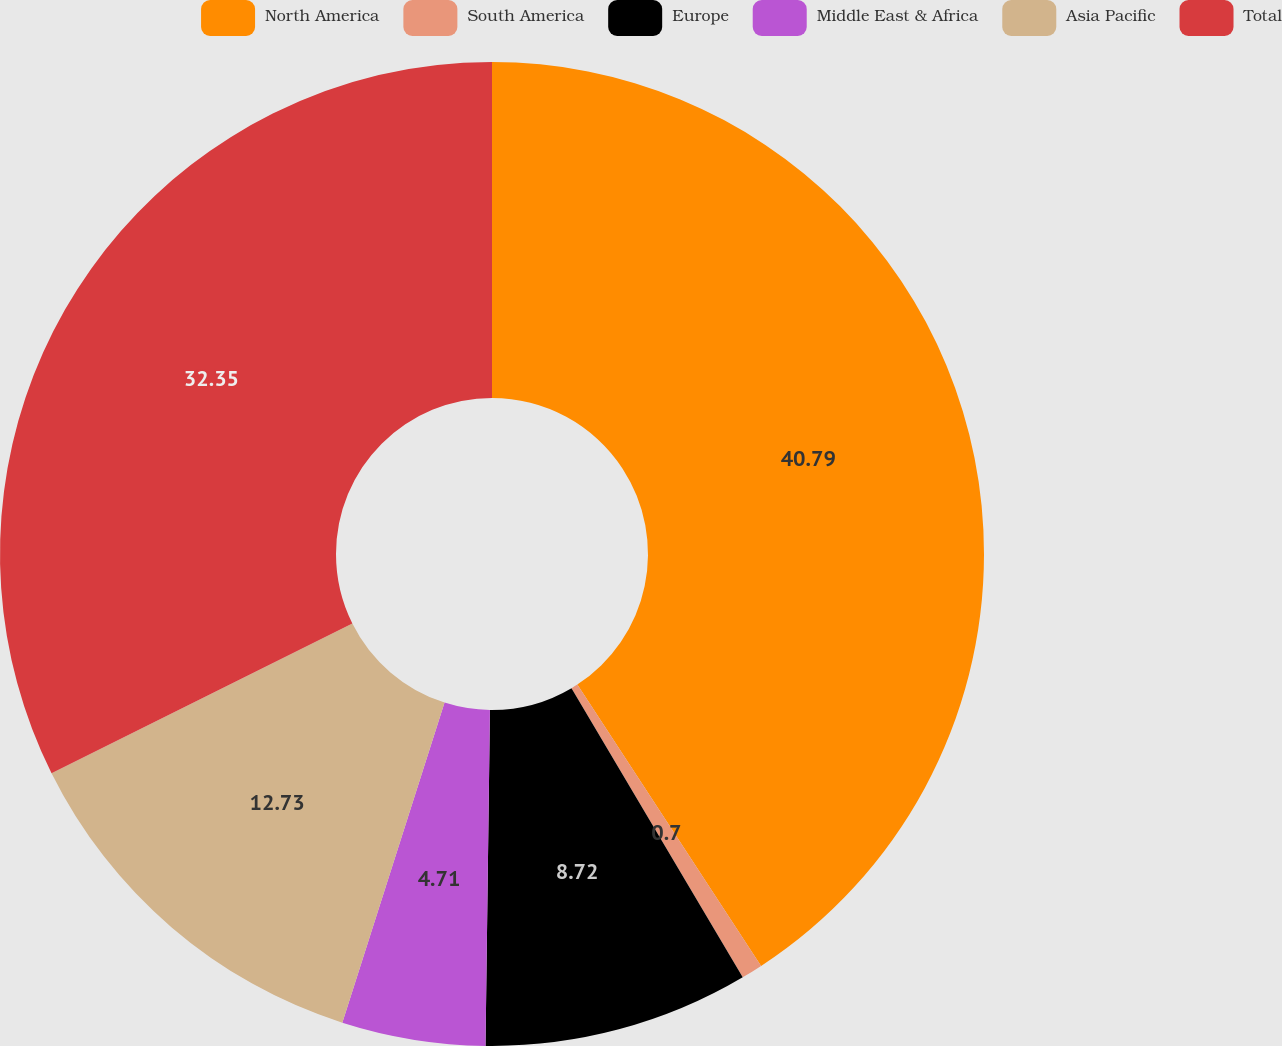Convert chart. <chart><loc_0><loc_0><loc_500><loc_500><pie_chart><fcel>North America<fcel>South America<fcel>Europe<fcel>Middle East & Africa<fcel>Asia Pacific<fcel>Total<nl><fcel>40.79%<fcel>0.7%<fcel>8.72%<fcel>4.71%<fcel>12.73%<fcel>32.35%<nl></chart> 